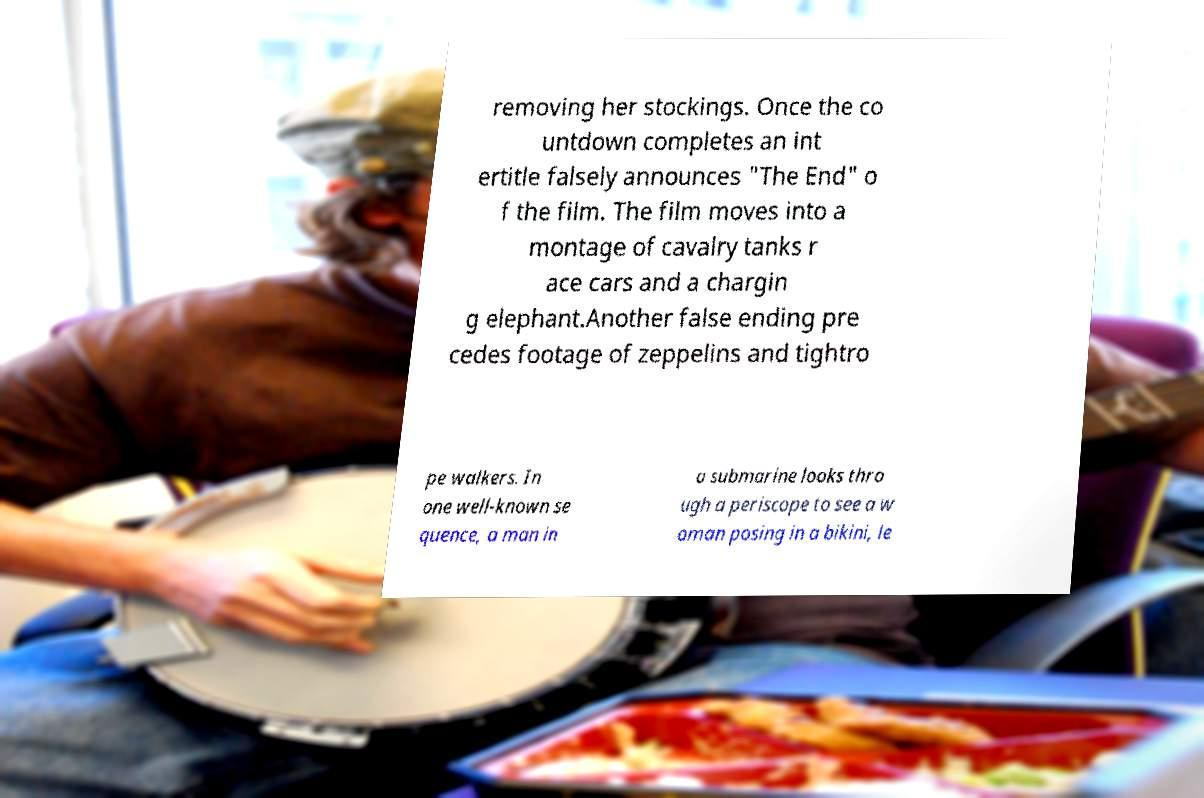Please read and relay the text visible in this image. What does it say? removing her stockings. Once the co untdown completes an int ertitle falsely announces "The End" o f the film. The film moves into a montage of cavalry tanks r ace cars and a chargin g elephant.Another false ending pre cedes footage of zeppelins and tightro pe walkers. In one well-known se quence, a man in a submarine looks thro ugh a periscope to see a w oman posing in a bikini, le 